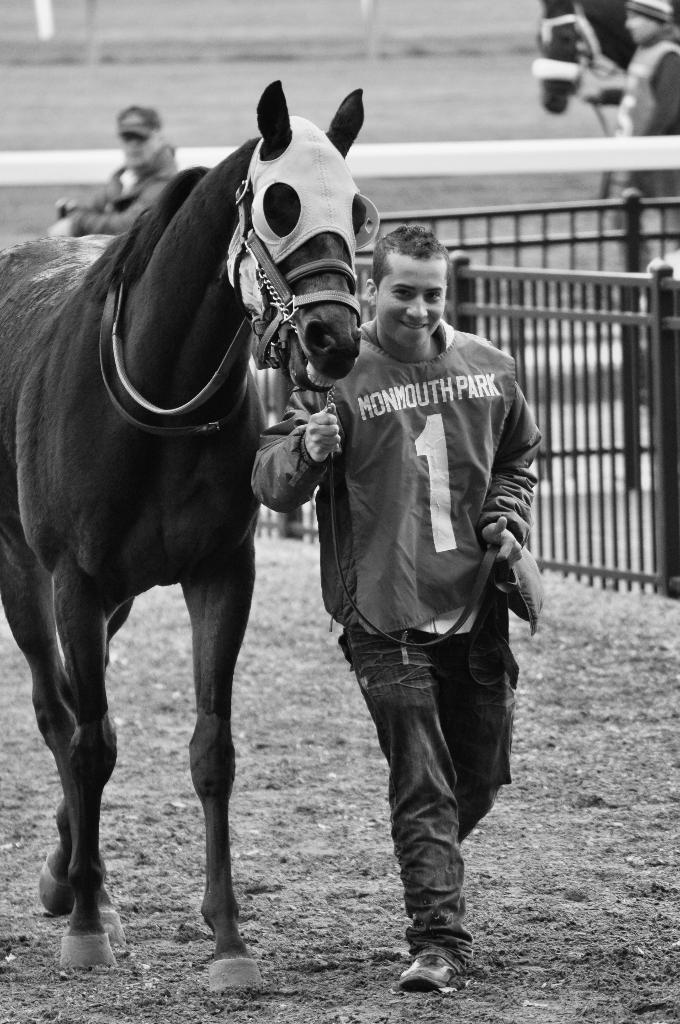What is the person in the image doing? The person is holding the leash of a horse. What can be seen in the background of the image? There is fencing, a man, and a horse in the background of the image. How many people are present in the image? There is one person holding the horse's leash, and another man in the background, making a total of two people. What part of the airplane can be seen in the image? There is no airplane present in the image; it features a person holding a horse's leash and a background with fencing, a man, and a horse. What type of school is depicted in the image? There is no school present in the image; it features a person holding a horse's leash and a background with fencing, a man, and a horse. 